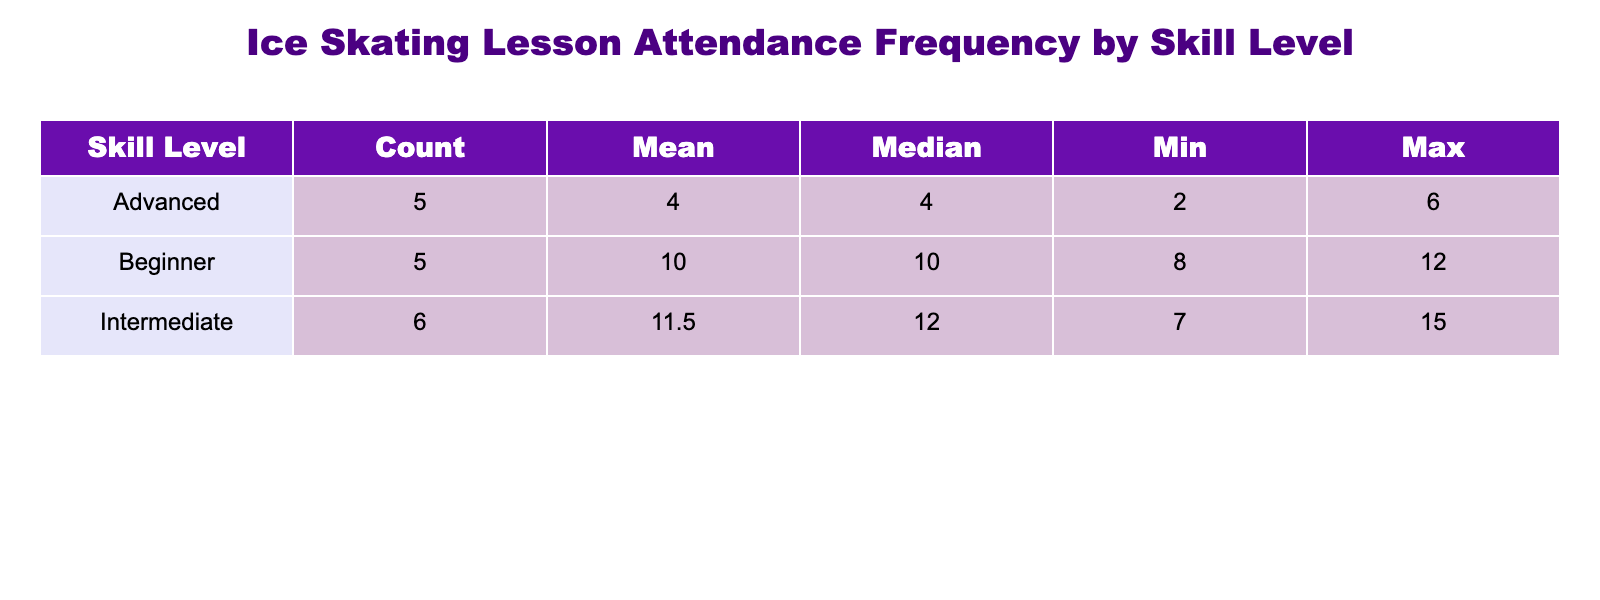What is the total attendance frequency for the Beginner skill level? To find the total attendance frequency for the Beginner skill level, we need to add all the frequencies associated with it: 12 + 10 + 8 + 9 + 11 = 50.
Answer: 50 What is the median attendance frequency for Intermediate skaters? The intermediate skaters' attendance frequencies are 15, 14, 13, 7, 11, 9. When we arrange them in order (7, 9, 11, 13, 14, 15), we have 6 data points; the median will be the average of the 3rd and 4th values: (11 + 13) / 2 = 12.
Answer: 12 Is the maximum attendance frequency for Advanced skaters greater than that for Beginners? The maximum attendance frequency for Advanced skaters is 6, while for Beginners, it is 12. Since 6 is not greater than 12, the answer is no.
Answer: No What is the average attendance frequency across all skill levels? First, sum up all attendance frequencies: 12 + 10 + 8 + 15 + 14 + 13 + 7 + 6 + 5 + 4 + 3 + 9 + 11 + 9 + 2 + 11 =  15 + 41 + 23 + 33 = 228. Since there are 15 entries, the average is 228 / 15 = 15.2.
Answer: 15.2 How many more attendees were recorded for the Beginner level compared to the Advanced level? The total attendance frequency for Beginners is 50 (as calculated), and for Advanced, it is 6 + 5 + 4 + 3 + 2 = 20. The difference is 50 - 20 = 30.
Answer: 30 What is the minimum attendance frequency recorded for Intermediate skaters? Looking at the frequencies for Intermediate, which are 15, 14, 13, 7, 11, and 9, the smallest value is 7, so the minimum is 7.
Answer: 7 How many Intermediate skaters had an attendance frequency less than 10? From the Intermediate frequencies (15, 14, 13, 7, 11, and 9), only 7 and 9 are below 10. Therefore, there are 2 skaters with less than 10 attendance frequency.
Answer: 2 What is the range of attendance frequencies for Advanced skaters? The range is calculated by subtracting the minimum frequency from the maximum frequency of Advanced skaters. The maximum is 6 and the minimum is 2, hence the range is 6 - 2 = 4.
Answer: 4 How many total attendees are recorded for all skill levels combined? The total is computed by summing each attendance frequency: 12 + 10 + 8 + 15 + 14 + 13 + 7 + 6 + 5 + 4 + 3 + 9 + 11 + 9 + 2 + 11 = 228.
Answer: 228 